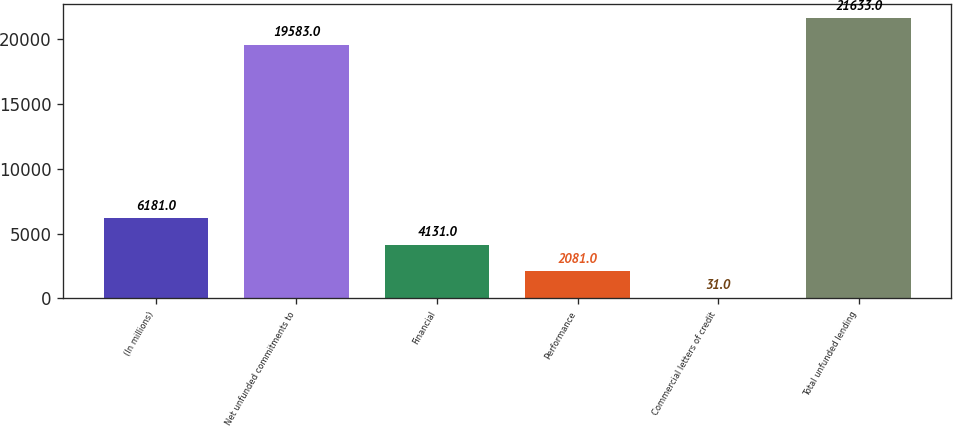Convert chart. <chart><loc_0><loc_0><loc_500><loc_500><bar_chart><fcel>(In millions)<fcel>Net unfunded commitments to<fcel>Financial<fcel>Performance<fcel>Commercial letters of credit<fcel>Total unfunded lending<nl><fcel>6181<fcel>19583<fcel>4131<fcel>2081<fcel>31<fcel>21633<nl></chart> 